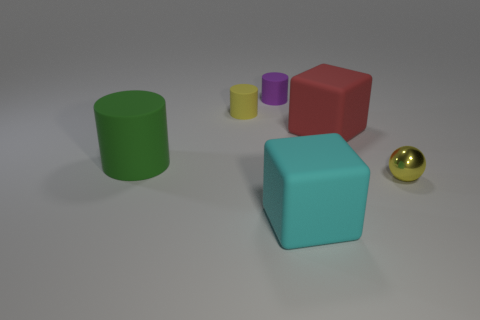Are there any yellow rubber things that have the same shape as the large cyan thing?
Keep it short and to the point. No. There is a red rubber thing; does it have the same shape as the yellow object that is behind the tiny metal ball?
Offer a terse response. No. How many balls are either large cyan matte objects or tiny purple objects?
Make the answer very short. 0. There is a yellow object to the right of the big red rubber object; what is its shape?
Offer a very short reply. Sphere. How many yellow objects are made of the same material as the red cube?
Offer a very short reply. 1. Are there fewer large green cylinders that are behind the large cylinder than tiny green metallic spheres?
Ensure brevity in your answer.  No. What size is the cube behind the cube in front of the red matte block?
Ensure brevity in your answer.  Large. There is a large cylinder; is it the same color as the matte cube that is behind the large cylinder?
Make the answer very short. No. There is a yellow cylinder that is the same size as the purple cylinder; what is its material?
Ensure brevity in your answer.  Rubber. Is the number of small yellow rubber things that are in front of the big green matte cylinder less than the number of tiny yellow matte objects on the right side of the yellow metallic sphere?
Your response must be concise. No. 